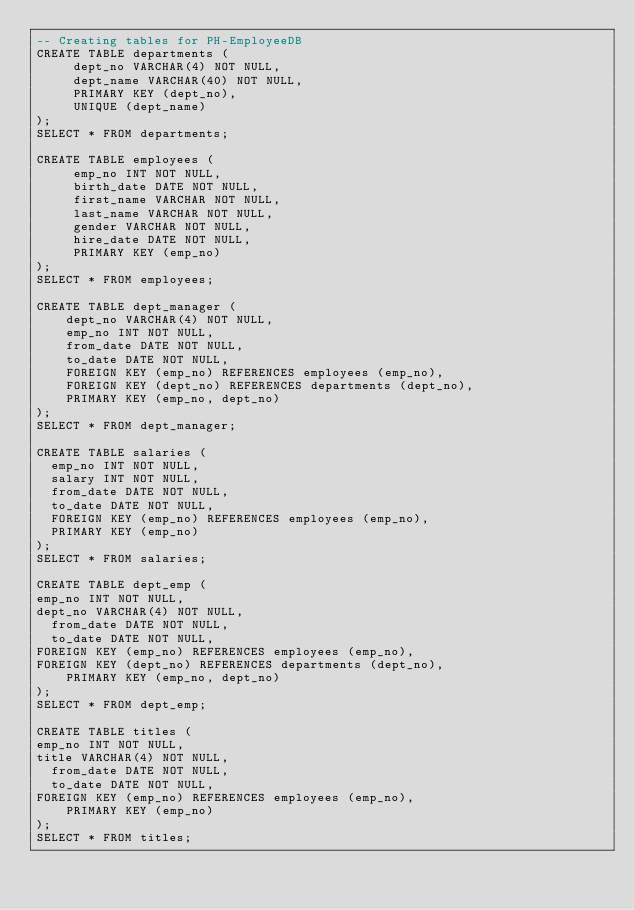<code> <loc_0><loc_0><loc_500><loc_500><_SQL_>-- Creating tables for PH-EmployeeDB
CREATE TABLE departments (
     dept_no VARCHAR(4) NOT NULL,
     dept_name VARCHAR(40) NOT NULL,
     PRIMARY KEY (dept_no),
     UNIQUE (dept_name)
);
SELECT * FROM departments;

CREATE TABLE employees (
     emp_no INT NOT NULL,
     birth_date DATE NOT NULL,
     first_name VARCHAR NOT NULL,
     last_name VARCHAR NOT NULL,
     gender VARCHAR NOT NULL,
     hire_date DATE NOT NULL,
     PRIMARY KEY (emp_no)
);
SELECT * FROM employees;

CREATE TABLE dept_manager (
    dept_no VARCHAR(4) NOT NULL,
    emp_no INT NOT NULL,
    from_date DATE NOT NULL,
    to_date DATE NOT NULL,
    FOREIGN KEY (emp_no) REFERENCES employees (emp_no),
    FOREIGN KEY (dept_no) REFERENCES departments (dept_no),
    PRIMARY KEY (emp_no, dept_no)
);
SELECT * FROM dept_manager;

CREATE TABLE salaries (
  emp_no INT NOT NULL,
  salary INT NOT NULL,
  from_date DATE NOT NULL,
  to_date DATE NOT NULL,
  FOREIGN KEY (emp_no) REFERENCES employees (emp_no),
  PRIMARY KEY (emp_no)
);
SELECT * FROM salaries;

CREATE TABLE dept_emp (
emp_no INT NOT NULL,
dept_no VARCHAR(4) NOT NULL,
  from_date DATE NOT NULL,
  to_date DATE NOT NULL,
FOREIGN KEY (emp_no) REFERENCES employees (emp_no),
FOREIGN KEY (dept_no) REFERENCES departments (dept_no),
    PRIMARY KEY (emp_no, dept_no)
);
SELECT * FROM dept_emp;

CREATE TABLE titles (
emp_no INT NOT NULL,
title VARCHAR(4) NOT NULL,
  from_date DATE NOT NULL,
  to_date DATE NOT NULL,
FOREIGN KEY (emp_no) REFERENCES employees (emp_no),
    PRIMARY KEY (emp_no)
);
SELECT * FROM titles;</code> 